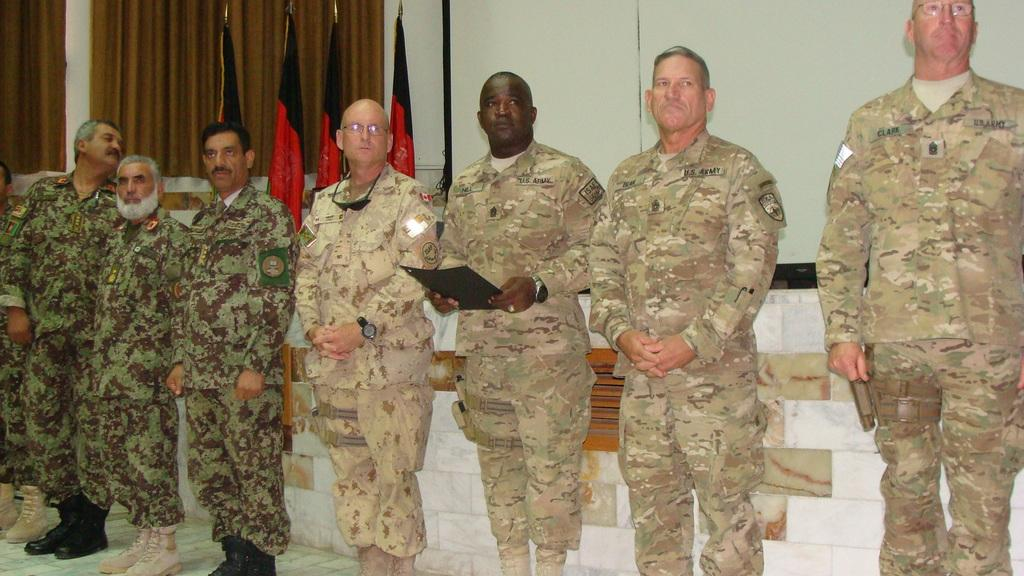How many people are visible in the image? There are people standing in the image, but the exact number is not specified. What is one person holding in the image? One person is holding a file in the image. What can be seen in the background of the image? There is a wall, flags, and curtains in the background of the image. What type of berry is being used as a paperweight on the file? There is no berry present in the image, and the file is not being held down by any object. What news story is being discussed by the people in the image? The image does not provide any information about a news story or a discussion taking place. 